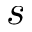<formula> <loc_0><loc_0><loc_500><loc_500>s</formula> 